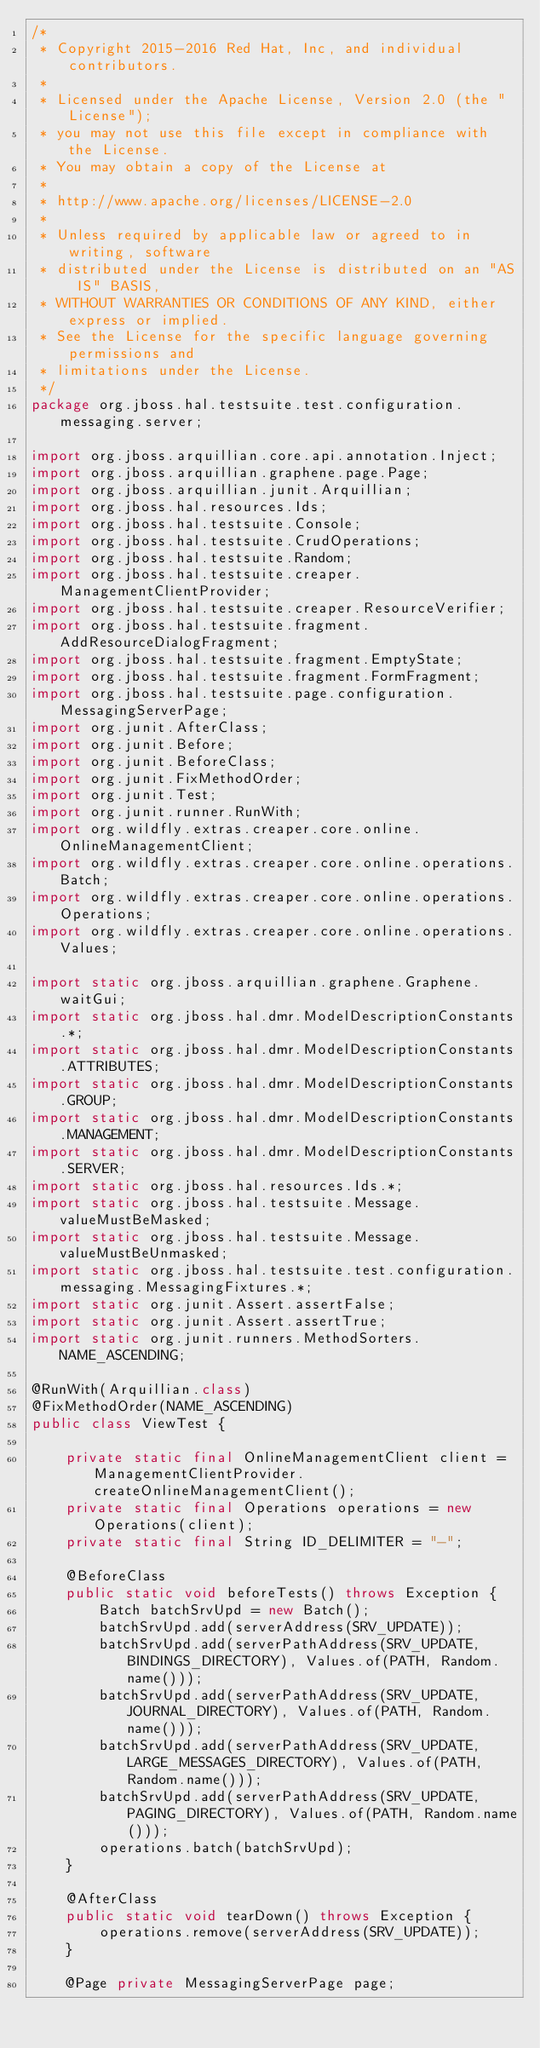<code> <loc_0><loc_0><loc_500><loc_500><_Java_>/*
 * Copyright 2015-2016 Red Hat, Inc, and individual contributors.
 *
 * Licensed under the Apache License, Version 2.0 (the "License");
 * you may not use this file except in compliance with the License.
 * You may obtain a copy of the License at
 *
 * http://www.apache.org/licenses/LICENSE-2.0
 *
 * Unless required by applicable law or agreed to in writing, software
 * distributed under the License is distributed on an "AS IS" BASIS,
 * WITHOUT WARRANTIES OR CONDITIONS OF ANY KIND, either express or implied.
 * See the License for the specific language governing permissions and
 * limitations under the License.
 */
package org.jboss.hal.testsuite.test.configuration.messaging.server;

import org.jboss.arquillian.core.api.annotation.Inject;
import org.jboss.arquillian.graphene.page.Page;
import org.jboss.arquillian.junit.Arquillian;
import org.jboss.hal.resources.Ids;
import org.jboss.hal.testsuite.Console;
import org.jboss.hal.testsuite.CrudOperations;
import org.jboss.hal.testsuite.Random;
import org.jboss.hal.testsuite.creaper.ManagementClientProvider;
import org.jboss.hal.testsuite.creaper.ResourceVerifier;
import org.jboss.hal.testsuite.fragment.AddResourceDialogFragment;
import org.jboss.hal.testsuite.fragment.EmptyState;
import org.jboss.hal.testsuite.fragment.FormFragment;
import org.jboss.hal.testsuite.page.configuration.MessagingServerPage;
import org.junit.AfterClass;
import org.junit.Before;
import org.junit.BeforeClass;
import org.junit.FixMethodOrder;
import org.junit.Test;
import org.junit.runner.RunWith;
import org.wildfly.extras.creaper.core.online.OnlineManagementClient;
import org.wildfly.extras.creaper.core.online.operations.Batch;
import org.wildfly.extras.creaper.core.online.operations.Operations;
import org.wildfly.extras.creaper.core.online.operations.Values;

import static org.jboss.arquillian.graphene.Graphene.waitGui;
import static org.jboss.hal.dmr.ModelDescriptionConstants.*;
import static org.jboss.hal.dmr.ModelDescriptionConstants.ATTRIBUTES;
import static org.jboss.hal.dmr.ModelDescriptionConstants.GROUP;
import static org.jboss.hal.dmr.ModelDescriptionConstants.MANAGEMENT;
import static org.jboss.hal.dmr.ModelDescriptionConstants.SERVER;
import static org.jboss.hal.resources.Ids.*;
import static org.jboss.hal.testsuite.Message.valueMustBeMasked;
import static org.jboss.hal.testsuite.Message.valueMustBeUnmasked;
import static org.jboss.hal.testsuite.test.configuration.messaging.MessagingFixtures.*;
import static org.junit.Assert.assertFalse;
import static org.junit.Assert.assertTrue;
import static org.junit.runners.MethodSorters.NAME_ASCENDING;

@RunWith(Arquillian.class)
@FixMethodOrder(NAME_ASCENDING)
public class ViewTest {

    private static final OnlineManagementClient client = ManagementClientProvider.createOnlineManagementClient();
    private static final Operations operations = new Operations(client);
    private static final String ID_DELIMITER = "-";

    @BeforeClass
    public static void beforeTests() throws Exception {
        Batch batchSrvUpd = new Batch();
        batchSrvUpd.add(serverAddress(SRV_UPDATE));
        batchSrvUpd.add(serverPathAddress(SRV_UPDATE, BINDINGS_DIRECTORY), Values.of(PATH, Random.name()));
        batchSrvUpd.add(serverPathAddress(SRV_UPDATE, JOURNAL_DIRECTORY), Values.of(PATH, Random.name()));
        batchSrvUpd.add(serverPathAddress(SRV_UPDATE, LARGE_MESSAGES_DIRECTORY), Values.of(PATH, Random.name()));
        batchSrvUpd.add(serverPathAddress(SRV_UPDATE, PAGING_DIRECTORY), Values.of(PATH, Random.name()));
        operations.batch(batchSrvUpd);
    }

    @AfterClass
    public static void tearDown() throws Exception {
        operations.remove(serverAddress(SRV_UPDATE));
    }

    @Page private MessagingServerPage page;</code> 